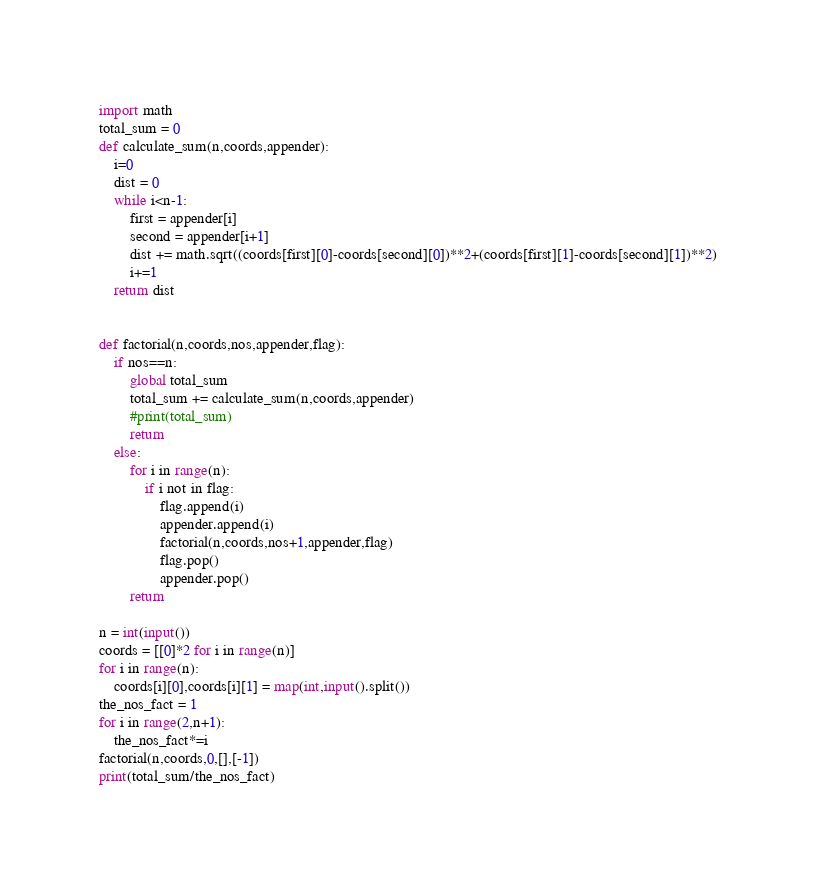<code> <loc_0><loc_0><loc_500><loc_500><_Python_>import math
total_sum = 0
def calculate_sum(n,coords,appender):
	i=0
	dist = 0
	while i<n-1:
		first = appender[i]
		second = appender[i+1]
		dist += math.sqrt((coords[first][0]-coords[second][0])**2+(coords[first][1]-coords[second][1])**2)
		i+=1
	return dist


def factorial(n,coords,nos,appender,flag):
	if nos==n:
		global total_sum
		total_sum += calculate_sum(n,coords,appender)
		#print(total_sum)
		return
	else:
		for i in range(n):
			if i not in flag:
				flag.append(i)
				appender.append(i)
				factorial(n,coords,nos+1,appender,flag)
				flag.pop()
				appender.pop()
		return

n = int(input())
coords = [[0]*2 for i in range(n)]
for i in range(n):
	coords[i][0],coords[i][1] = map(int,input().split())
the_nos_fact = 1
for i in range(2,n+1):
	the_nos_fact*=i
factorial(n,coords,0,[],[-1])
print(total_sum/the_nos_fact)</code> 